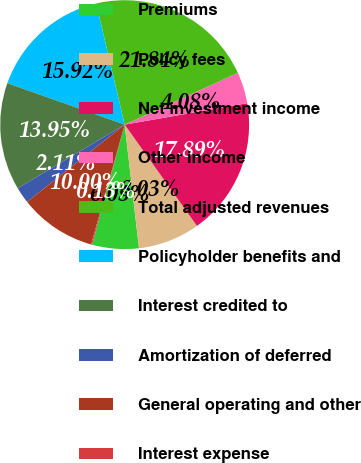Convert chart to OTSL. <chart><loc_0><loc_0><loc_500><loc_500><pie_chart><fcel>Premiums<fcel>Policy fees<fcel>Net investment income<fcel>Other income<fcel>Total adjusted revenues<fcel>Policyholder benefits and<fcel>Interest credited to<fcel>Amortization of deferred<fcel>General operating and other<fcel>Interest expense<nl><fcel>6.05%<fcel>8.03%<fcel>17.89%<fcel>4.08%<fcel>21.84%<fcel>15.92%<fcel>13.95%<fcel>2.11%<fcel>10.0%<fcel>0.13%<nl></chart> 